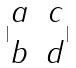Convert formula to latex. <formula><loc_0><loc_0><loc_500><loc_500>| \begin{matrix} a & c \\ b & d \end{matrix} |</formula> 